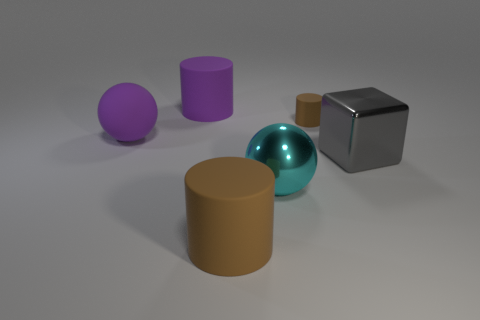Do the large purple thing that is in front of the purple cylinder and the cyan sphere have the same material?
Keep it short and to the point. No. Is the number of cyan balls that are right of the small matte cylinder less than the number of cubes?
Your response must be concise. Yes. There is a object in front of the large cyan object; what shape is it?
Keep it short and to the point. Cylinder. There is a brown rubber object that is the same size as the metallic cube; what shape is it?
Your response must be concise. Cylinder. Is there a tiny metal thing of the same shape as the large gray metal thing?
Your answer should be compact. No. Does the shiny object that is behind the cyan shiny object have the same shape as the brown matte thing that is in front of the large cyan shiny thing?
Your answer should be compact. No. There is a brown thing that is the same size as the purple matte cylinder; what is it made of?
Provide a short and direct response. Rubber. What number of other things are the same material as the purple cylinder?
Keep it short and to the point. 3. What shape is the purple matte object that is left of the cylinder that is on the left side of the big brown object?
Offer a terse response. Sphere. How many things are either brown metal objects or cylinders that are behind the large gray shiny thing?
Give a very brief answer. 2. 